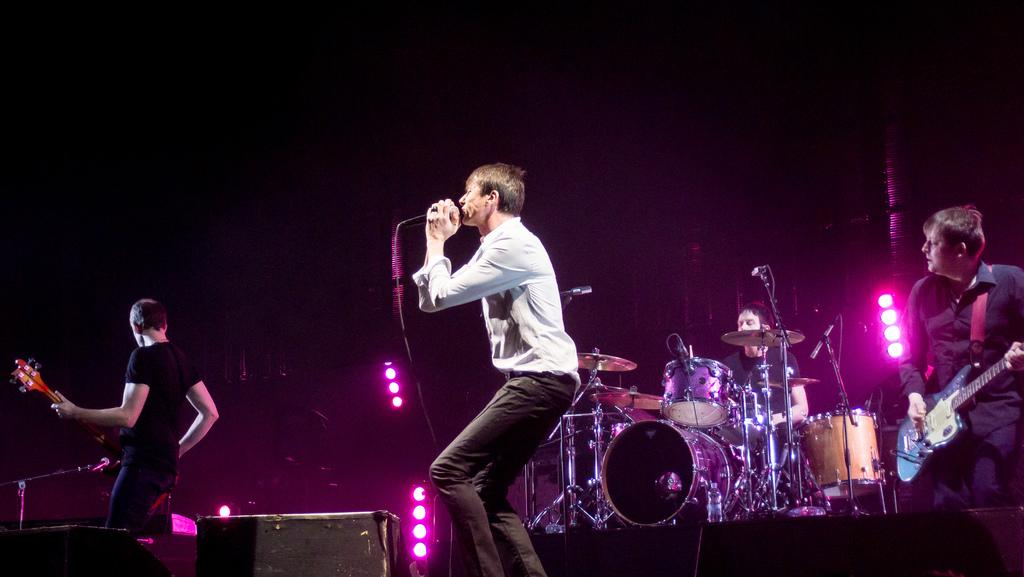What is the man in the image wearing? The man is wearing a white shirt. What is the man doing in the image? The man is singing. What object is the man in front of? The man is in front of a microphone. How many people are playing musical instruments in the image? There are three persons playing musical instruments. What can be seen in the background of the image? There are focusing lights in the background. Can you see any trees or an arch in the image? There are no trees or arches visible in the image. What type of monkey is sitting on the man's shoulder in the image? There is no monkey present in the image. 